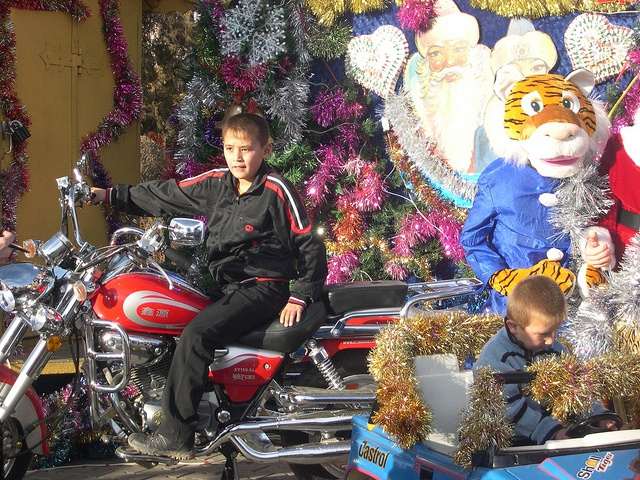Describe the objects in this image and their specific colors. I can see motorcycle in maroon, black, gray, darkgray, and white tones, people in maroon, black, and gray tones, people in maroon, white, lightblue, darkgray, and blue tones, and people in maroon, gray, and black tones in this image. 